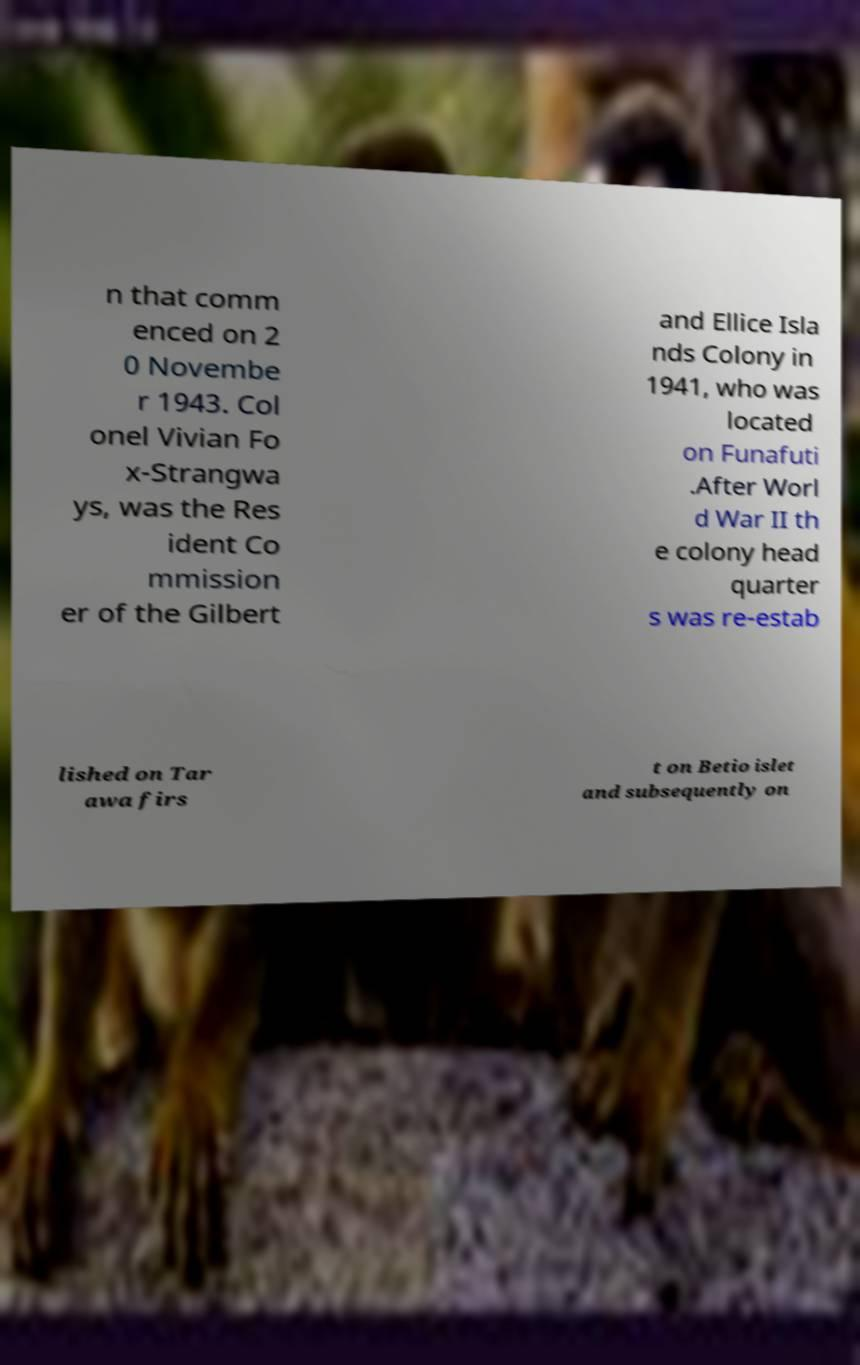Could you extract and type out the text from this image? n that comm enced on 2 0 Novembe r 1943. Col onel Vivian Fo x-Strangwa ys, was the Res ident Co mmission er of the Gilbert and Ellice Isla nds Colony in 1941, who was located on Funafuti .After Worl d War II th e colony head quarter s was re-estab lished on Tar awa firs t on Betio islet and subsequently on 